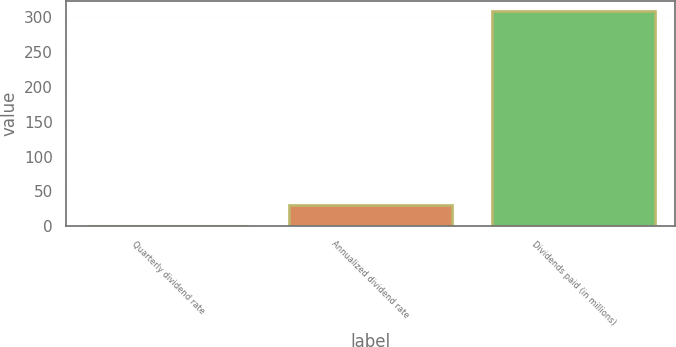Convert chart. <chart><loc_0><loc_0><loc_500><loc_500><bar_chart><fcel>Quarterly dividend rate<fcel>Annualized dividend rate<fcel>Dividends paid (in millions)<nl><fcel>0.28<fcel>31.05<fcel>308<nl></chart> 